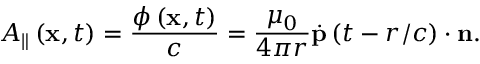<formula> <loc_0><loc_0><loc_500><loc_500>A _ { \| } \left ( x , t \right ) = \frac { \phi \left ( x , t \right ) } { c } = \frac { \mu _ { 0 } } { 4 \pi r } \overset { . } { p } \left ( t - r / c \right ) \cdot n .</formula> 